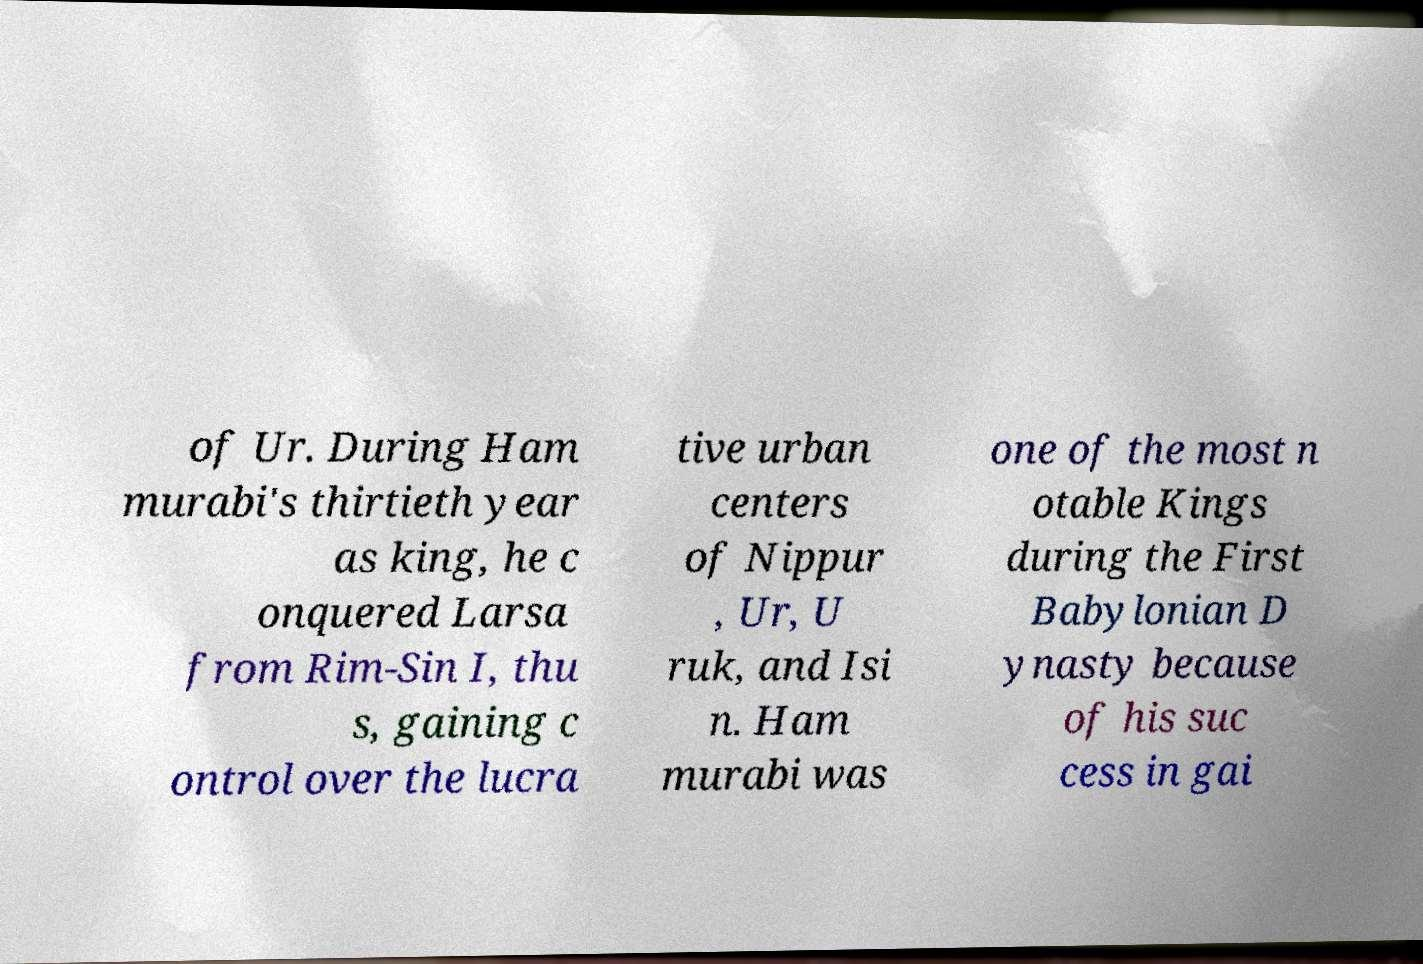Could you assist in decoding the text presented in this image and type it out clearly? of Ur. During Ham murabi's thirtieth year as king, he c onquered Larsa from Rim-Sin I, thu s, gaining c ontrol over the lucra tive urban centers of Nippur , Ur, U ruk, and Isi n. Ham murabi was one of the most n otable Kings during the First Babylonian D ynasty because of his suc cess in gai 